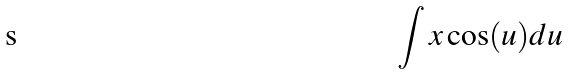<formula> <loc_0><loc_0><loc_500><loc_500>\int x \cos ( u ) d u</formula> 